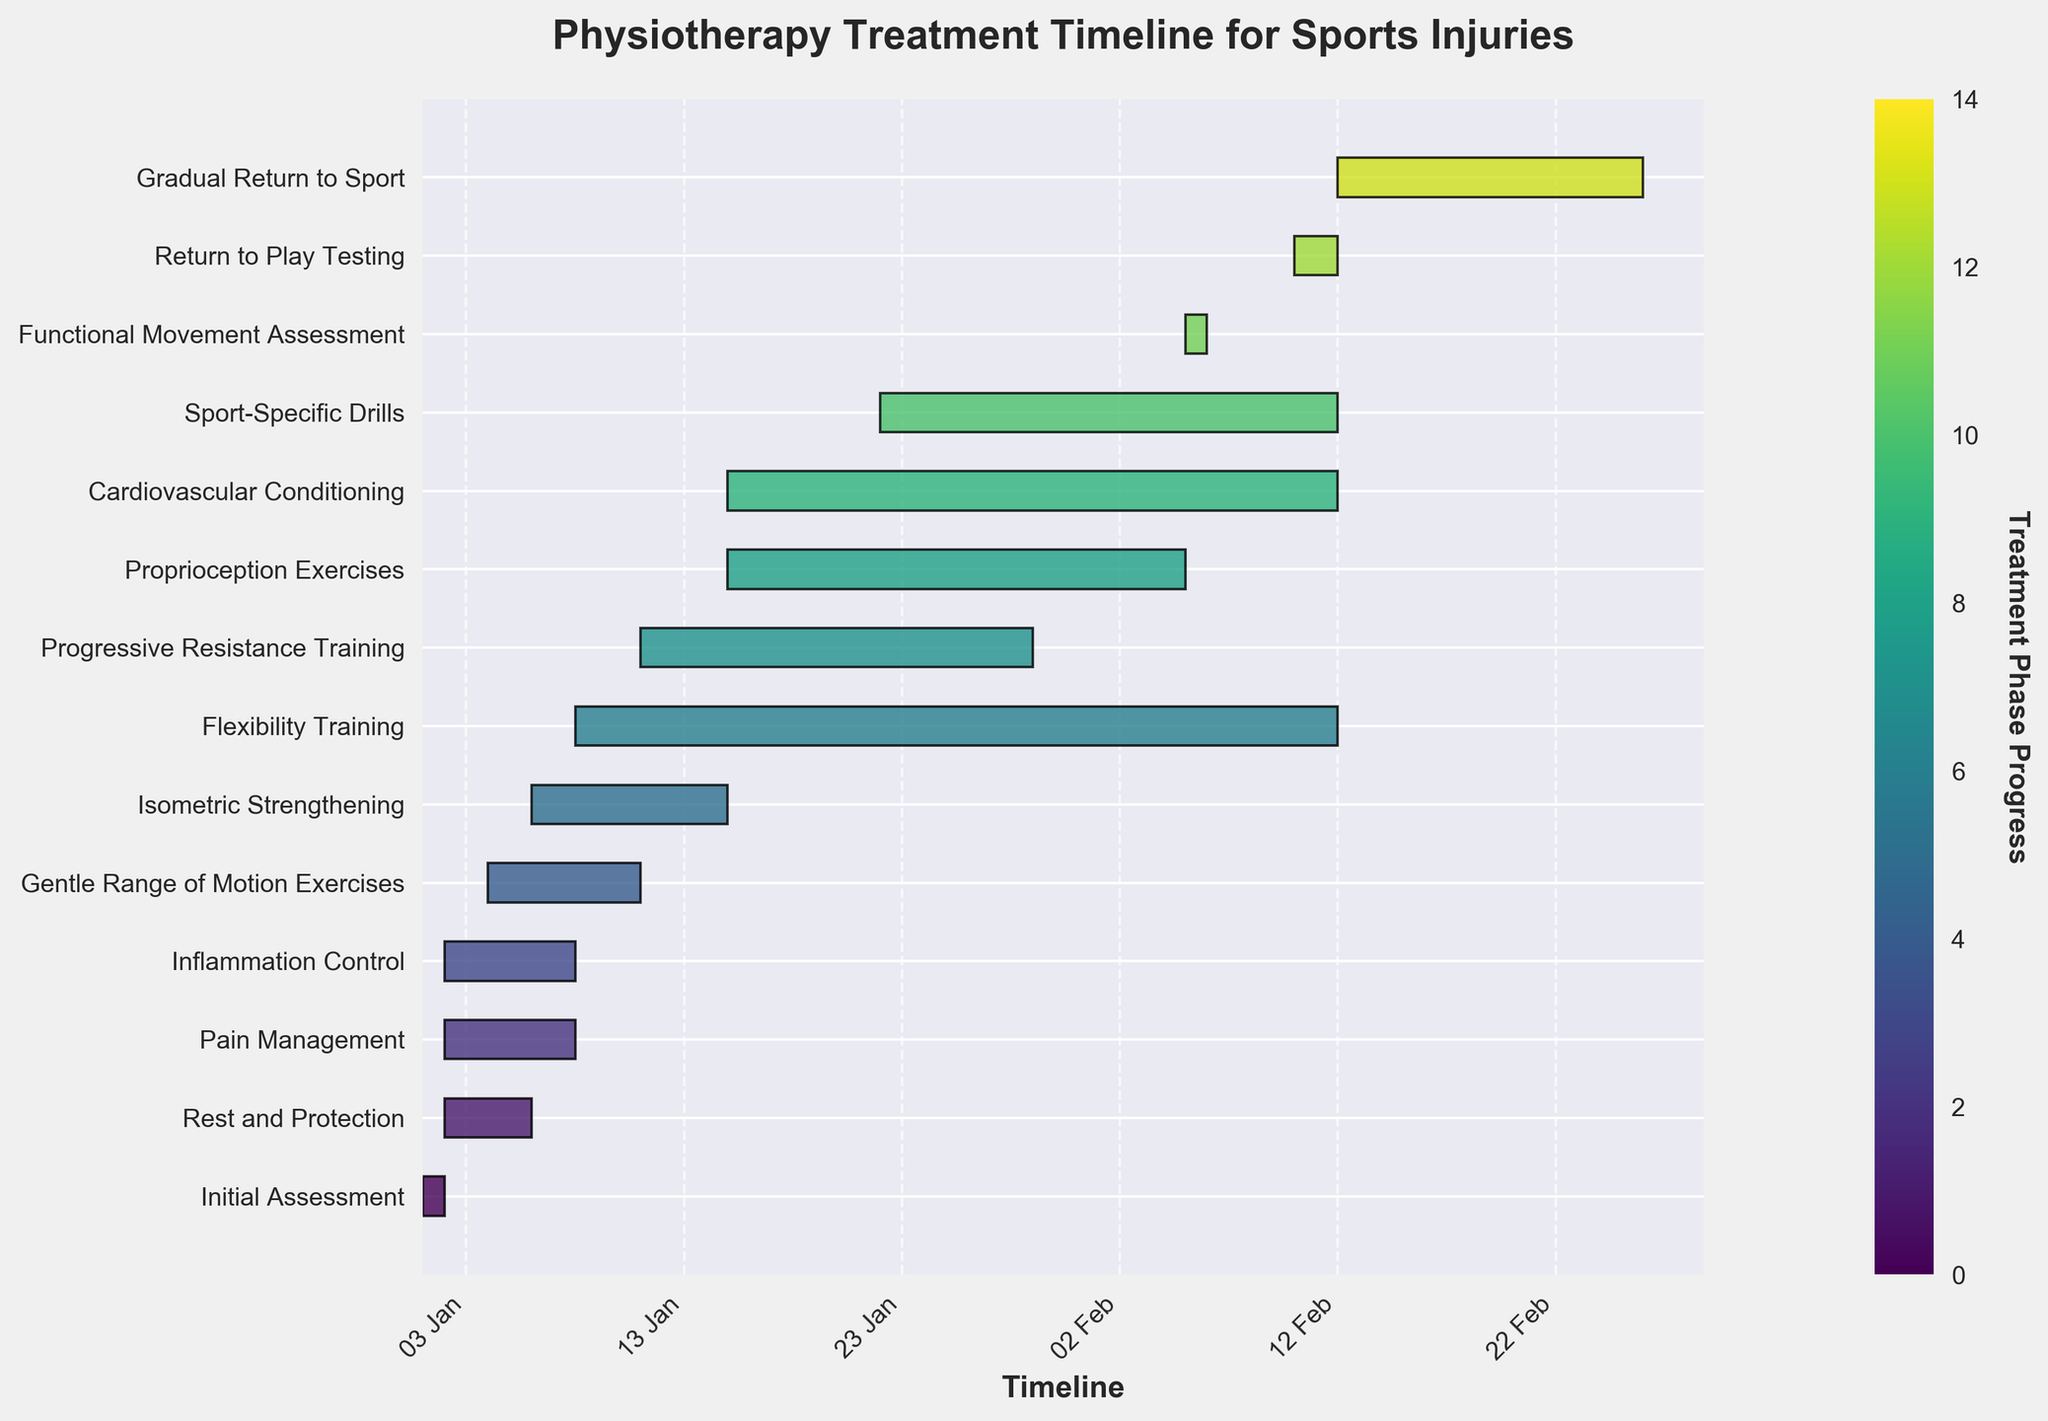What is the title of the Gantt chart? The title is usually located at the top of the chart, indicating the subject of the visualization. In this case, it shows that the chart is about the timeline of different phases in physiotherapy treatment for sports injuries.
Answer: Physiotherapy Treatment Timeline for Sports Injuries How many tasks are listed in the Gantt chart? The number of tasks (phases) can be determined by counting the labeled bars on the y-axis. Each task is associated with a different stage of the physiotherapy treatment for sports injuries.
Answer: 14 When does the 'Return to Play Testing' phase start and end? Locate the 'Return to Play Testing' task along the y-axis and read the corresponding start and end dates on the x-axis. This phase should have a bar indicating its duration.
Answer: Day 40 to Day 42 Which phase overlaps with both the 'Pain Management' and 'Inflammation Control' phases? Check the bars representing 'Pain Management' and 'Inflammation Control'. Identify any phase(s) with bars that overlap in terms of their duration with both these phases.
Answer: Rest and Protection How long is the 'Progressive Resistance Training' phase? Determine the start and end dates of 'Progressive Resistance Training' and calculate the difference in days. This can be found by reading the x-axis dates associated with this phase's bar.
Answer: 18 days What phase directly follows the 'Initial Assessment'? Look at the tasks listed and identify which phase starts immediately after the end date of the 'Initial Assessment' phase.
Answer: Rest and Protection How many phases start on Day 1? Count the number of tasks whose bars start at or include the date marked as Day 1 on the x-axis. These bars represent the phases that initiate on this specific day.
Answer: 3 Which phase is the longest in duration? By visually comparing the lengths of the bars representing each phase, identify which bar spans the most extended period from its start to end dates.
Answer: Gradual Return to Sport What is the duration of the 'Functional Movement Assessment' phase? Find the 'Functional Movement Assessment' bar and note its start and end dates on the x-axis. Calculate the number of days between these dates.
Answer: 1 day How many days are there between the end of 'Cardiovascular Conditioning' and the start of 'Gradual Return to Sport'? Identify the end date of 'Cardiovascular Conditioning' and the start date of 'Gradual Return to Sport', then calculate the gap in days between these two dates.
Answer: 0 days 